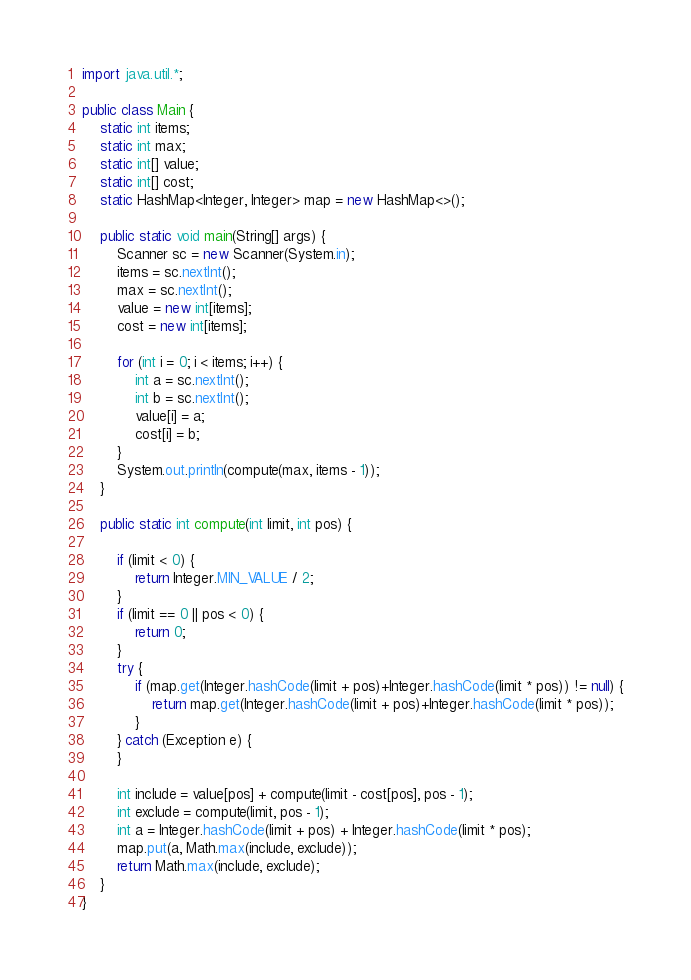Convert code to text. <code><loc_0><loc_0><loc_500><loc_500><_Java_>import java.util.*;

public class Main {
	static int items;
	static int max;
	static int[] value;
	static int[] cost;
	static HashMap<Integer, Integer> map = new HashMap<>();

	public static void main(String[] args) {
		Scanner sc = new Scanner(System.in);
		items = sc.nextInt();
		max = sc.nextInt();
		value = new int[items];
		cost = new int[items];

		for (int i = 0; i < items; i++) {
			int a = sc.nextInt();
			int b = sc.nextInt();
			value[i] = a;
			cost[i] = b;
		}
		System.out.println(compute(max, items - 1));
	}

	public static int compute(int limit, int pos) {

		if (limit < 0) {
			return Integer.MIN_VALUE / 2;
		}
		if (limit == 0 || pos < 0) {
			return 0;
		}
		try {
			if (map.get(Integer.hashCode(limit + pos)+Integer.hashCode(limit * pos)) != null) {
				return map.get(Integer.hashCode(limit + pos)+Integer.hashCode(limit * pos));
			}
		} catch (Exception e) {
		}

		int include = value[pos] + compute(limit - cost[pos], pos - 1);
		int exclude = compute(limit, pos - 1);
		int a = Integer.hashCode(limit + pos) + Integer.hashCode(limit * pos);
		map.put(a, Math.max(include, exclude));
		return Math.max(include, exclude);
	}
}
</code> 